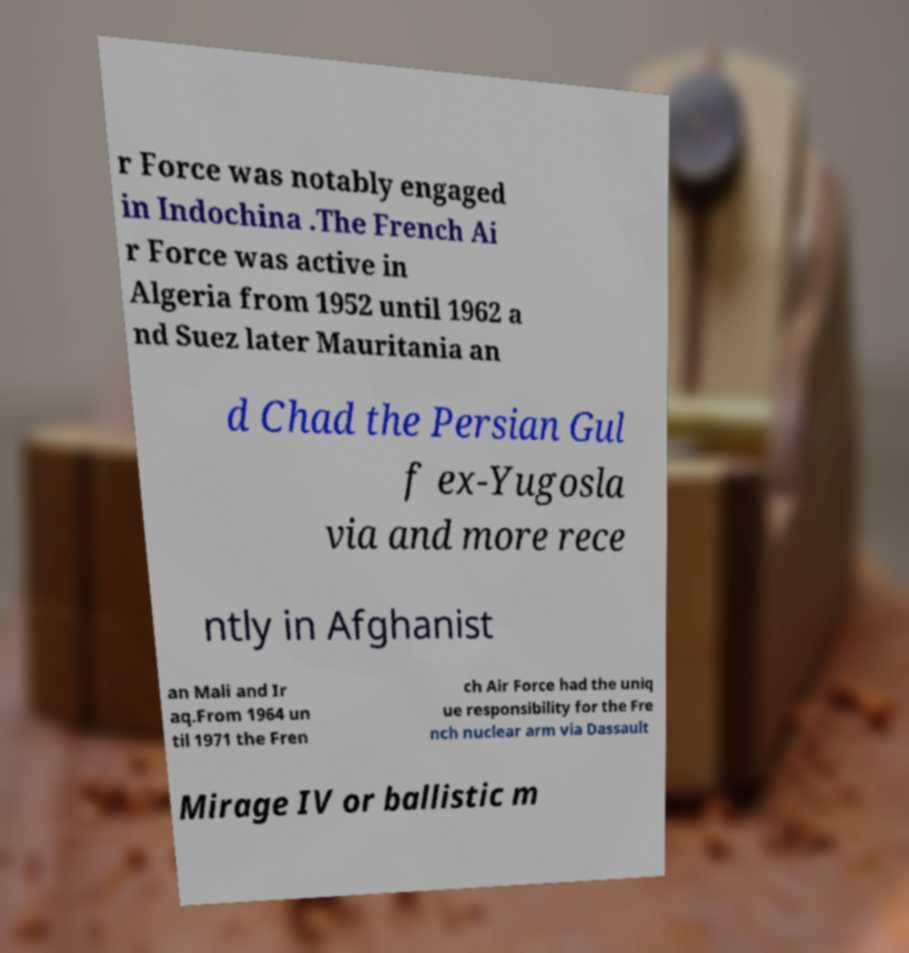For documentation purposes, I need the text within this image transcribed. Could you provide that? r Force was notably engaged in Indochina .The French Ai r Force was active in Algeria from 1952 until 1962 a nd Suez later Mauritania an d Chad the Persian Gul f ex-Yugosla via and more rece ntly in Afghanist an Mali and Ir aq.From 1964 un til 1971 the Fren ch Air Force had the uniq ue responsibility for the Fre nch nuclear arm via Dassault Mirage IV or ballistic m 